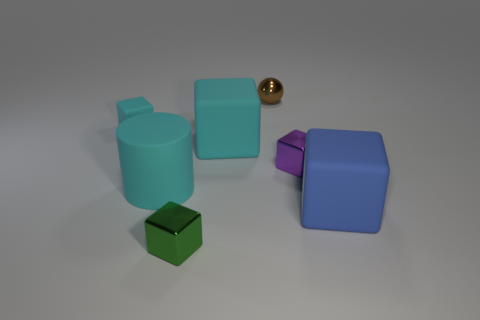Subtract all tiny matte cubes. How many cubes are left? 4 Subtract all purple cubes. How many cubes are left? 4 Subtract all yellow cubes. Subtract all blue cylinders. How many cubes are left? 5 Add 1 tiny green shiny objects. How many objects exist? 8 Subtract all balls. How many objects are left? 6 Add 7 tiny metal blocks. How many tiny metal blocks exist? 9 Subtract 0 blue cylinders. How many objects are left? 7 Subtract all tiny green blocks. Subtract all brown shiny spheres. How many objects are left? 5 Add 1 tiny brown objects. How many tiny brown objects are left? 2 